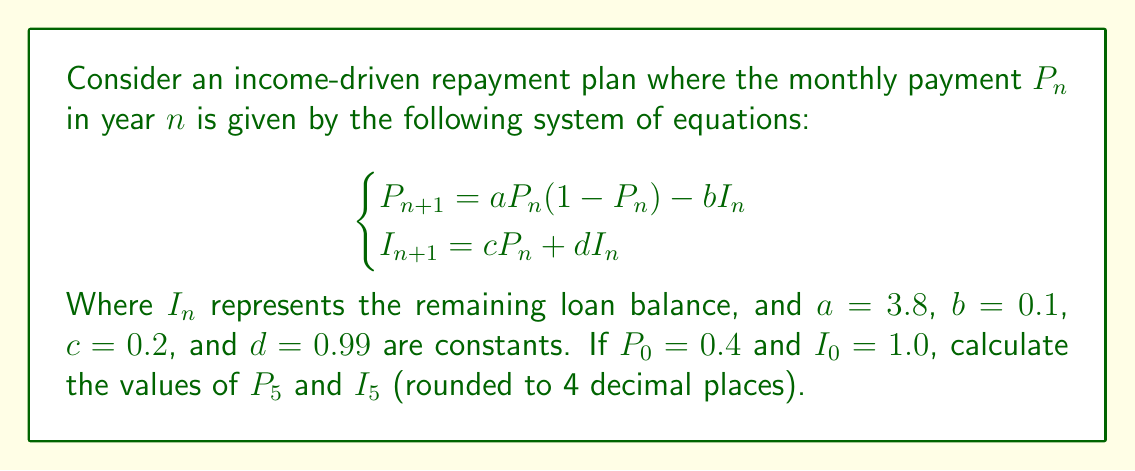What is the answer to this math problem? To solve this problem, we need to iterate the system of equations for 5 years. Let's go through it step by step:

1) For n = 0:
   $P_0 = 0.4$
   $I_0 = 1.0$

2) For n = 1:
   $P_1 = aP_0(1-P_0) - bI_0 = 3.8 * 0.4 * (1-0.4) - 0.1 * 1.0 = 0.812$
   $I_1 = cP_0 + dI_0 = 0.2 * 0.4 + 0.99 * 1.0 = 1.07$

3) For n = 2:
   $P_2 = aP_1(1-P_1) - bI_1 = 3.8 * 0.812 * (1-0.812) - 0.1 * 1.07 = 0.4636$
   $I_2 = cP_1 + dI_1 = 0.2 * 0.812 + 0.99 * 1.07 = 1.2213$

4) For n = 3:
   $P_3 = aP_2(1-P_2) - bI_2 = 3.8 * 0.4636 * (1-0.4636) - 0.1 * 1.2213 = 0.8389$
   $I_3 = cP_2 + dI_2 = 0.2 * 0.4636 + 0.99 * 1.2213 = 1.3018$

5) For n = 4:
   $P_4 = aP_3(1-P_3) - bI_3 = 3.8 * 0.8389 * (1-0.8389) - 0.1 * 1.3018 = 0.3944$
   $I_4 = cP_3 + dI_3 = 0.2 * 0.8389 + 0.99 * 1.3018 = 1.4575$

6) For n = 5:
   $P_5 = aP_4(1-P_4) - bI_4 = 3.8 * 0.3944 * (1-0.3944) - 0.1 * 1.4575 = 0.7557$
   $I_5 = cP_4 + dI_4 = 0.2 * 0.3944 + 0.99 * 1.4575 = 1.5228$

Rounding to 4 decimal places:
$P_5 = 0.7557$
$I_5 = 1.5228$
Answer: $P_5 = 0.7557$, $I_5 = 1.5228$ 